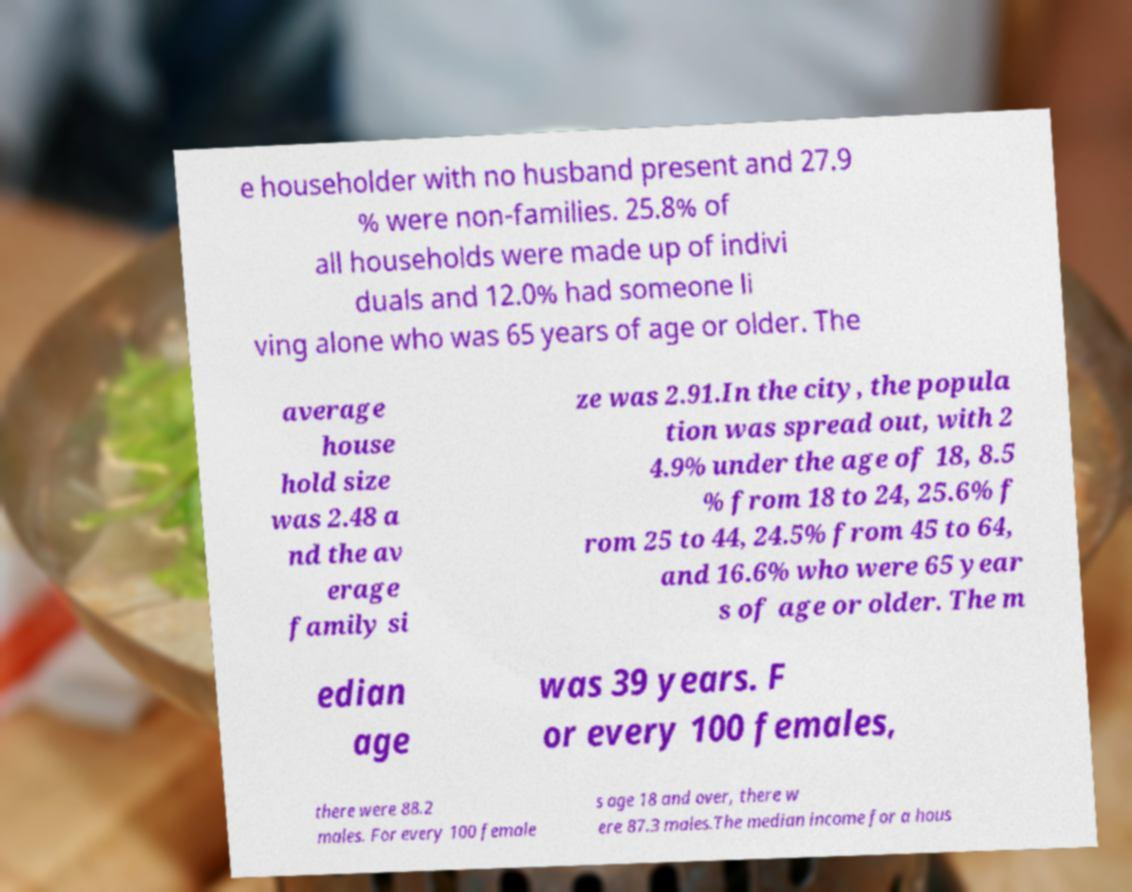What messages or text are displayed in this image? I need them in a readable, typed format. e householder with no husband present and 27.9 % were non-families. 25.8% of all households were made up of indivi duals and 12.0% had someone li ving alone who was 65 years of age or older. The average house hold size was 2.48 a nd the av erage family si ze was 2.91.In the city, the popula tion was spread out, with 2 4.9% under the age of 18, 8.5 % from 18 to 24, 25.6% f rom 25 to 44, 24.5% from 45 to 64, and 16.6% who were 65 year s of age or older. The m edian age was 39 years. F or every 100 females, there were 88.2 males. For every 100 female s age 18 and over, there w ere 87.3 males.The median income for a hous 